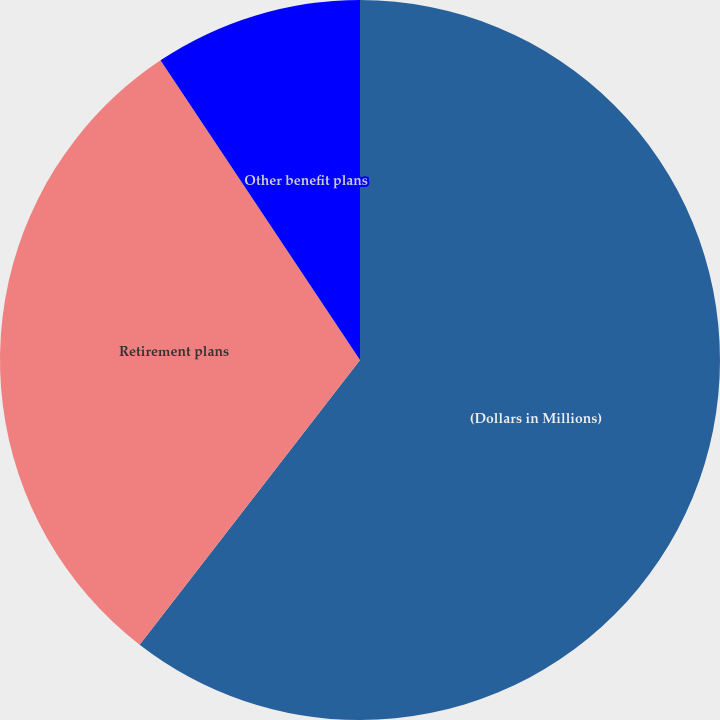Convert chart to OTSL. <chart><loc_0><loc_0><loc_500><loc_500><pie_chart><fcel>(Dollars in Millions)<fcel>Retirement plans<fcel>Other benefit plans<nl><fcel>60.49%<fcel>30.17%<fcel>9.35%<nl></chart> 